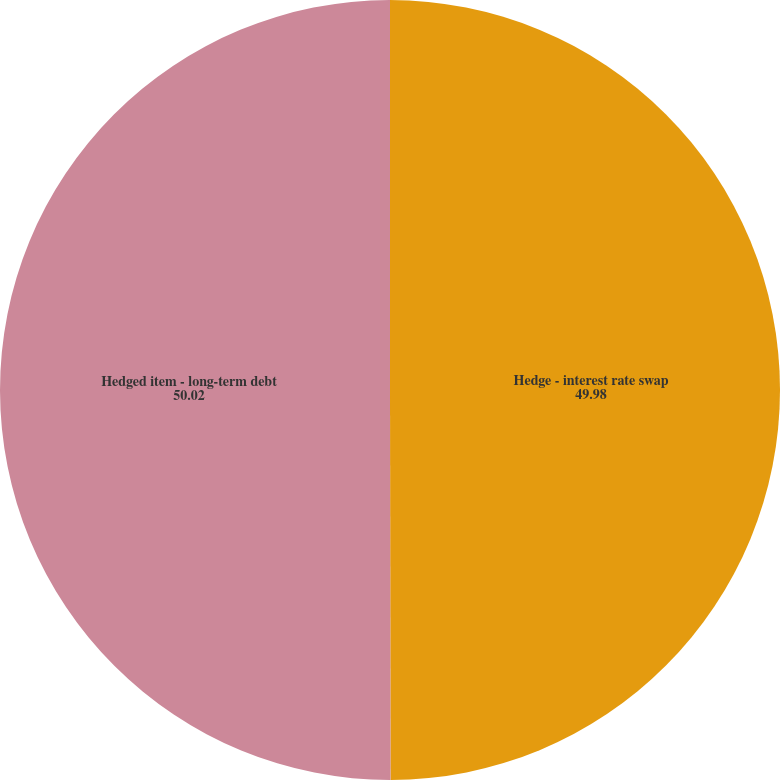<chart> <loc_0><loc_0><loc_500><loc_500><pie_chart><fcel>Hedge - interest rate swap<fcel>Hedged item - long-term debt<nl><fcel>49.98%<fcel>50.02%<nl></chart> 